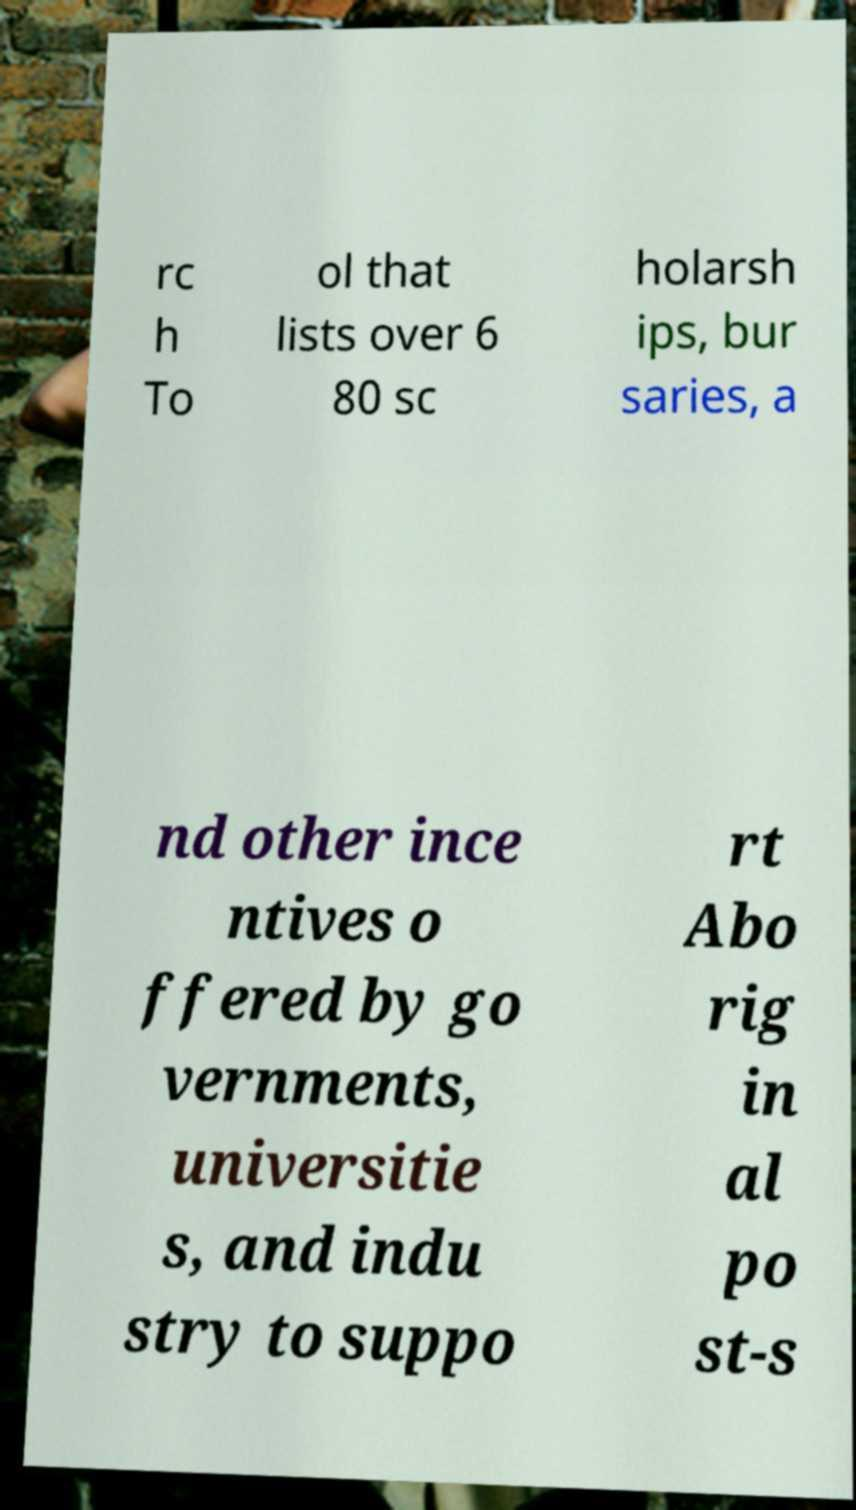Could you extract and type out the text from this image? rc h To ol that lists over 6 80 sc holarsh ips, bur saries, a nd other ince ntives o ffered by go vernments, universitie s, and indu stry to suppo rt Abo rig in al po st-s 